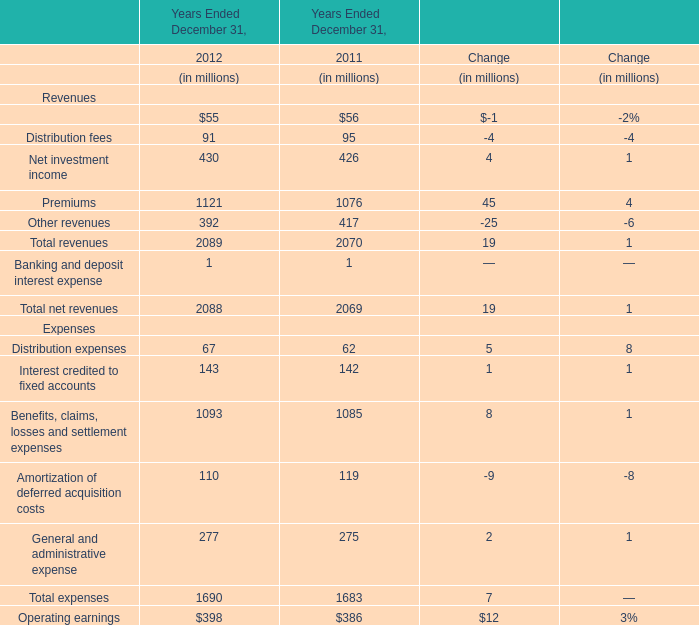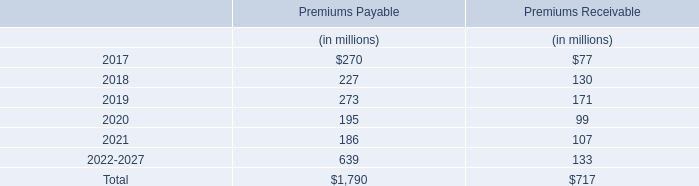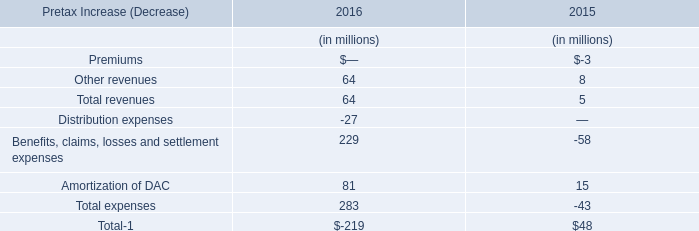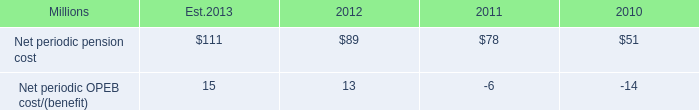What is the sum of Management and financial advice fees for Revenues in 2012 and Other revenues in 2016? (in million) 
Computations: (64 + 55)
Answer: 119.0. 